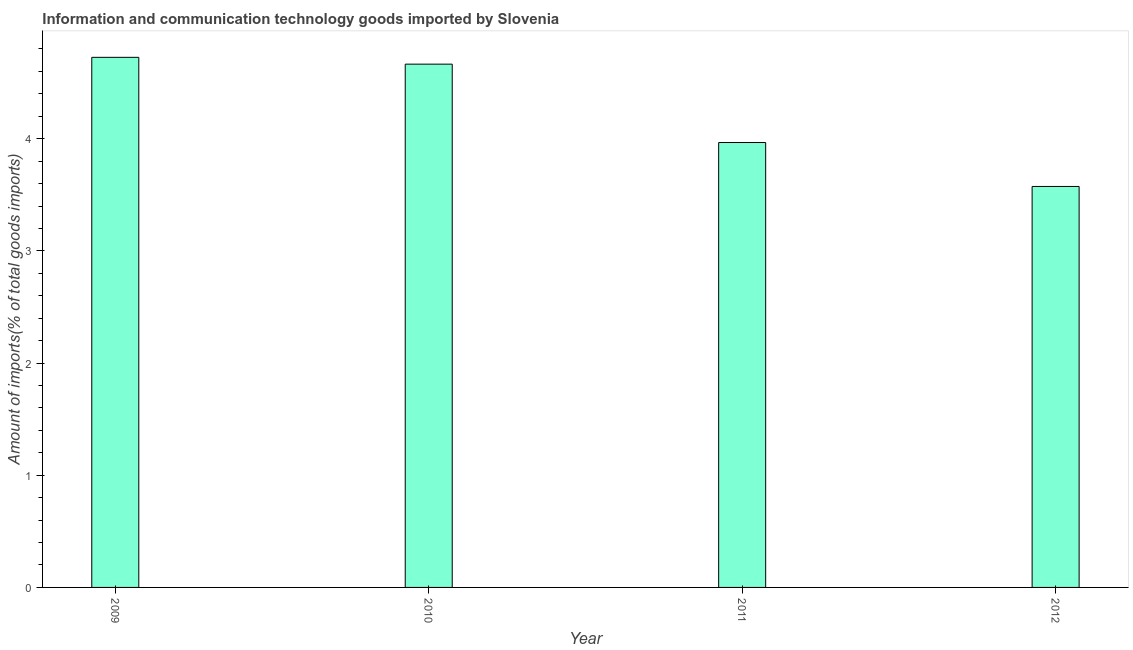Does the graph contain any zero values?
Ensure brevity in your answer.  No. What is the title of the graph?
Your response must be concise. Information and communication technology goods imported by Slovenia. What is the label or title of the X-axis?
Make the answer very short. Year. What is the label or title of the Y-axis?
Provide a short and direct response. Amount of imports(% of total goods imports). What is the amount of ict goods imports in 2010?
Make the answer very short. 4.66. Across all years, what is the maximum amount of ict goods imports?
Keep it short and to the point. 4.73. Across all years, what is the minimum amount of ict goods imports?
Ensure brevity in your answer.  3.57. What is the sum of the amount of ict goods imports?
Make the answer very short. 16.93. What is the difference between the amount of ict goods imports in 2009 and 2010?
Give a very brief answer. 0.06. What is the average amount of ict goods imports per year?
Give a very brief answer. 4.23. What is the median amount of ict goods imports?
Offer a terse response. 4.32. What is the ratio of the amount of ict goods imports in 2009 to that in 2012?
Offer a very short reply. 1.32. Is the amount of ict goods imports in 2009 less than that in 2010?
Make the answer very short. No. What is the difference between the highest and the second highest amount of ict goods imports?
Keep it short and to the point. 0.06. Is the sum of the amount of ict goods imports in 2009 and 2012 greater than the maximum amount of ict goods imports across all years?
Provide a short and direct response. Yes. What is the difference between the highest and the lowest amount of ict goods imports?
Offer a terse response. 1.15. In how many years, is the amount of ict goods imports greater than the average amount of ict goods imports taken over all years?
Your answer should be compact. 2. Are all the bars in the graph horizontal?
Ensure brevity in your answer.  No. What is the difference between two consecutive major ticks on the Y-axis?
Provide a succinct answer. 1. Are the values on the major ticks of Y-axis written in scientific E-notation?
Your answer should be very brief. No. What is the Amount of imports(% of total goods imports) in 2009?
Your answer should be compact. 4.73. What is the Amount of imports(% of total goods imports) in 2010?
Provide a short and direct response. 4.66. What is the Amount of imports(% of total goods imports) in 2011?
Provide a short and direct response. 3.97. What is the Amount of imports(% of total goods imports) of 2012?
Provide a short and direct response. 3.57. What is the difference between the Amount of imports(% of total goods imports) in 2009 and 2010?
Your answer should be compact. 0.06. What is the difference between the Amount of imports(% of total goods imports) in 2009 and 2011?
Provide a succinct answer. 0.76. What is the difference between the Amount of imports(% of total goods imports) in 2009 and 2012?
Offer a terse response. 1.15. What is the difference between the Amount of imports(% of total goods imports) in 2010 and 2011?
Ensure brevity in your answer.  0.7. What is the difference between the Amount of imports(% of total goods imports) in 2010 and 2012?
Offer a very short reply. 1.09. What is the difference between the Amount of imports(% of total goods imports) in 2011 and 2012?
Offer a very short reply. 0.39. What is the ratio of the Amount of imports(% of total goods imports) in 2009 to that in 2011?
Provide a succinct answer. 1.19. What is the ratio of the Amount of imports(% of total goods imports) in 2009 to that in 2012?
Provide a short and direct response. 1.32. What is the ratio of the Amount of imports(% of total goods imports) in 2010 to that in 2011?
Provide a short and direct response. 1.18. What is the ratio of the Amount of imports(% of total goods imports) in 2010 to that in 2012?
Keep it short and to the point. 1.3. What is the ratio of the Amount of imports(% of total goods imports) in 2011 to that in 2012?
Your response must be concise. 1.11. 